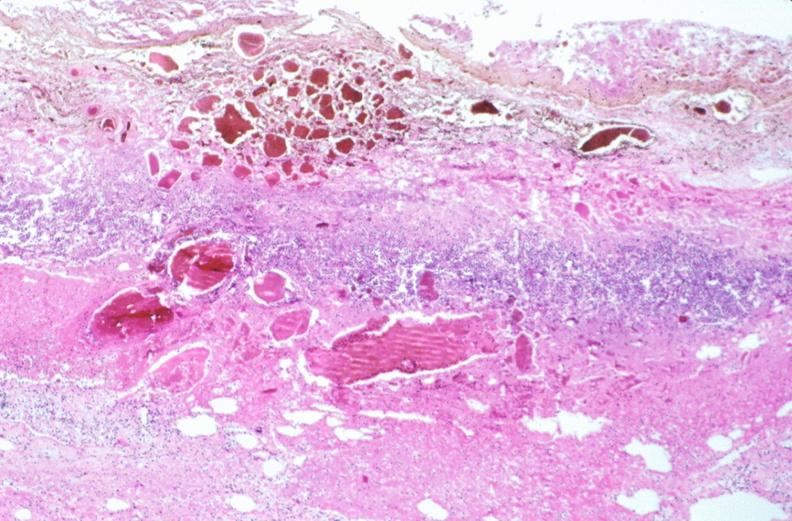s gastrointestinal present?
Answer the question using a single word or phrase. Yes 